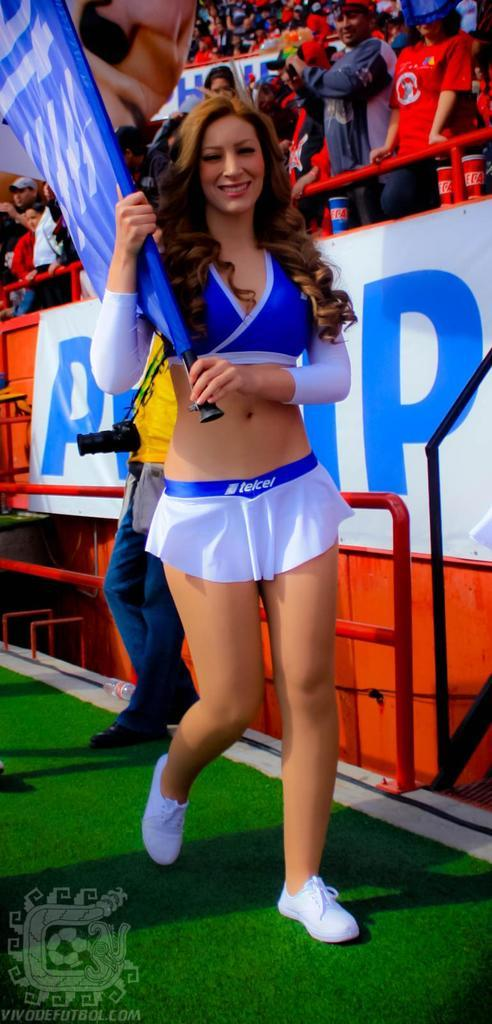Provide a one-sentence caption for the provided image. A cheerleader holding a flag and wearing a Telcel skirt. 